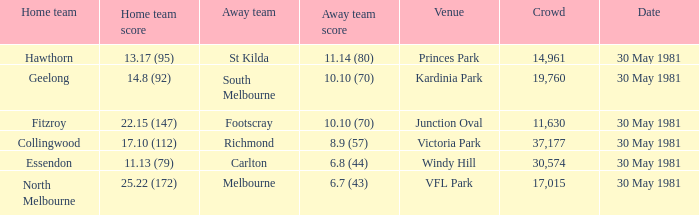What team played away at vfl park? Melbourne. 